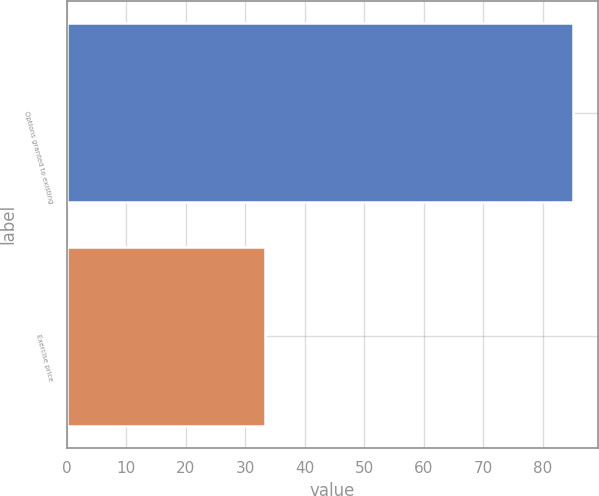Convert chart. <chart><loc_0><loc_0><loc_500><loc_500><bar_chart><fcel>Options granted to existing<fcel>Exercise price<nl><fcel>85<fcel>33.23<nl></chart> 